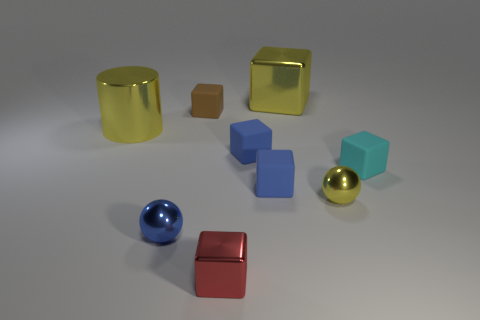Is there a big metallic cylinder that has the same color as the large metal cube?
Your answer should be very brief. Yes. What color is the tiny metal block?
Your answer should be very brief. Red. There is a small block that is made of the same material as the large yellow cylinder; what is its color?
Provide a short and direct response. Red. What number of big yellow cubes are the same material as the tiny brown thing?
Offer a very short reply. 0. How many yellow shiny spheres are on the left side of the small brown matte thing?
Give a very brief answer. 0. Is the cyan block behind the small red metallic block made of the same material as the small object on the left side of the small brown rubber cube?
Offer a very short reply. No. Is the number of small metallic balls on the left side of the small red thing greater than the number of large yellow cylinders that are right of the yellow metal cylinder?
Keep it short and to the point. Yes. What material is the large cube that is the same color as the big cylinder?
Offer a terse response. Metal. There is a tiny block that is both behind the cyan object and in front of the yellow cylinder; what is its material?
Ensure brevity in your answer.  Rubber. Is the material of the red thing the same as the object on the right side of the tiny yellow sphere?
Make the answer very short. No. 